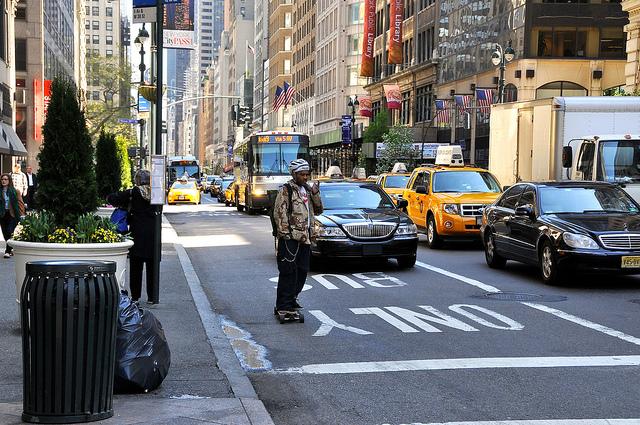What vehicle is the left most lane reserved for?
Give a very brief answer. Bus. What are the yellow cars?
Short answer required. Cabs. Did the skateboarder get in the way?
Be succinct. No. 